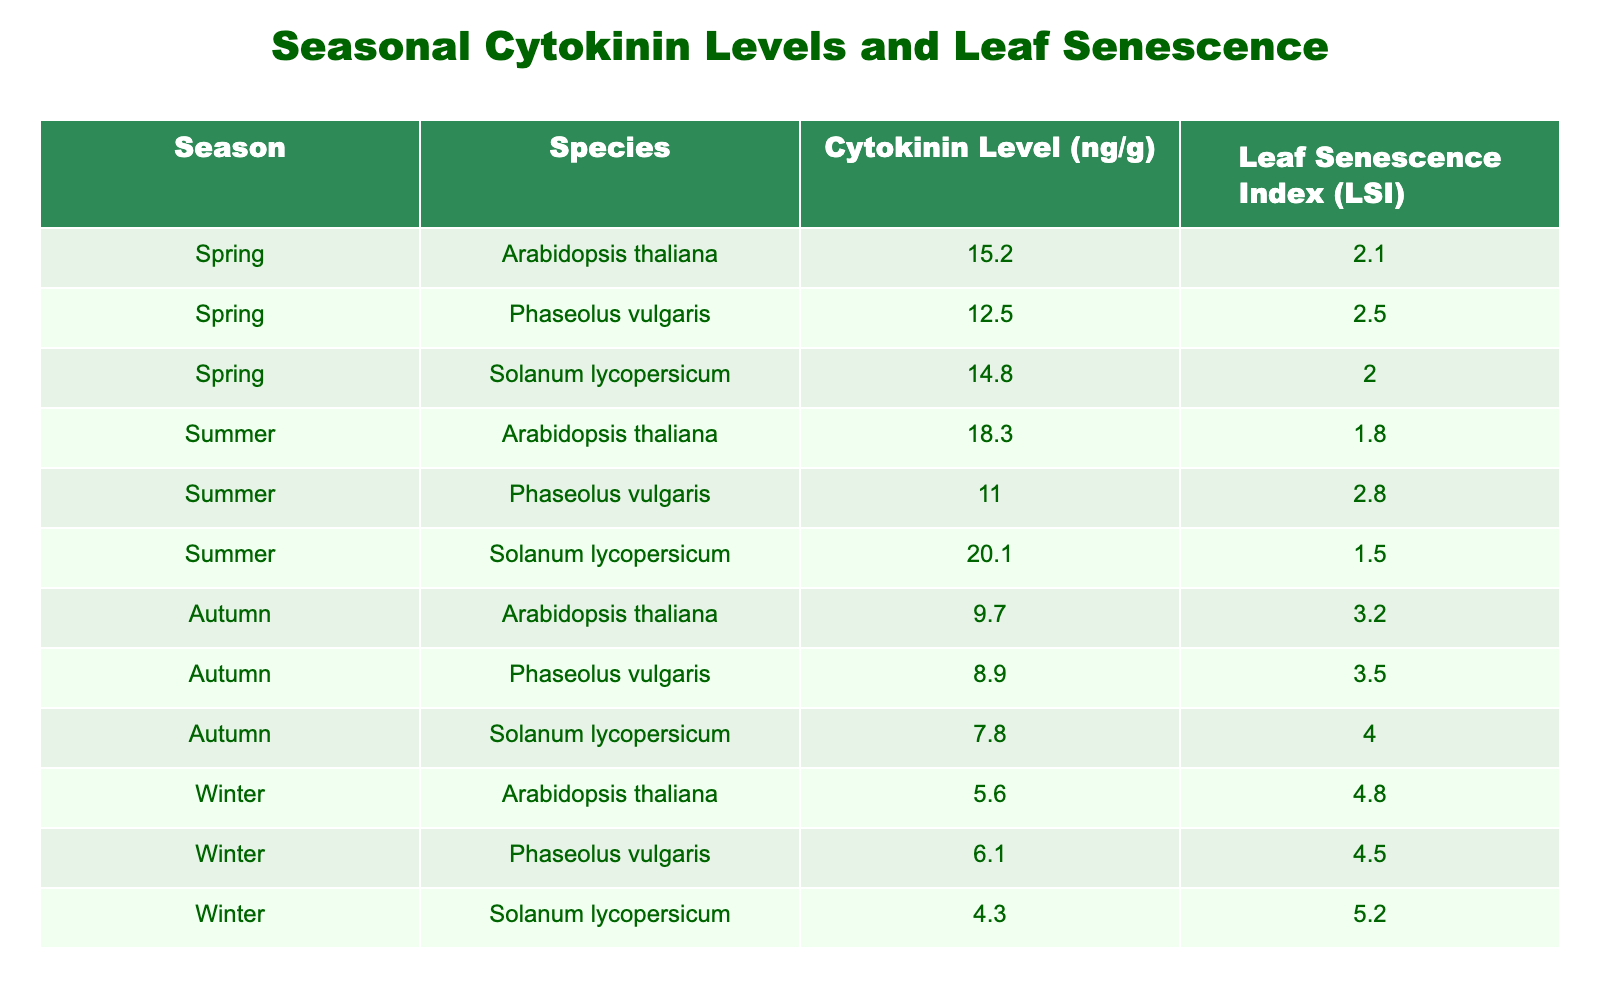What is the cytokinin level for Arabidopsis thaliana in autumn? In the table, look for the row where the species is Arabidopsis thaliana and the season is autumn. The cytokinin level listed in that row is 9.7 ng/g.
Answer: 9.7 ng/g What is the Leaf Senescence Index for Solanum lycopersicum in summer? The table indicates that for Solanum lycopersicum during the summer season, the Leaf Senescence Index (LSI) is listed as 1.5.
Answer: 1.5 Which species exhibited the highest cytokinin level in spring? To determine this, compare the cytokinin levels of all species listed for the spring season. Arabidopsis thaliana at 15.2 ng/g has the highest value among them.
Answer: Arabidopsis thaliana What is the average cytokinin level across all species in winter? First, we find the cytokinin levels for winter: 5.6, 6.1, and 4.3 ng/g. The sum is (5.6 + 6.1 + 4.3) = 16.0. Since there are 3 data points, the average is 16.0 / 3 ≈ 5.33 ng/g.
Answer: 5.33 ng/g Is it true that Phaseolus vulgaris has a lower Leaf Senescence Index in spring than in autumn? Checking the LSI values: Phaseolus vulgaris has an LSI of 2.5 in spring and 3.5 in autumn. Since 2.5 is lower than 3.5, the statement is true.
Answer: Yes What is the difference in cytokinin levels between the highest and lowest values observed across all seasons for Solanum lycopersicum? The highest cytokinin level for Solanum lycopersicum is in summer at 20.1 ng/g, and the lowest is in autumn at 7.8 ng/g. The difference is 20.1 - 7.8 = 12.3 ng/g.
Answer: 12.3 ng/g Which season had the lowest average Leaf Senescence Index across all species? Calculate the average LSI for each season: Spring: (2.1 + 2.5 + 2.0) / 3 = 2.2, Summer: (1.8 + 2.8 + 1.5) / 3 = 2.03, Autumn: (3.2 + 3.5 + 4.0) / 3 = 3.23, Winter: (4.8 + 4.5 + 5.2) / 3 = 4.5. Summer had the lowest average LSI of 2.03.
Answer: Summer What is the trend of cytokinin levels from spring to winter for Arabidopsis thaliana? Observing the table, the cytokinin levels for Arabidopsis thaliana are 15.2 in spring, 18.3 in summer, 9.7 in autumn, and 5.6 in winter. The trend shows a peak in summer followed by a decline in autumn and winter.
Answer: Declining trend How does the Leaf Senescence Index for Phaseolus vulgaris change from summer to winter? The LSI for Phaseolus vulgaris in summer is 2.8, and in winter, it is 4.5. So, there is an increase in the index going from summer to winter.
Answer: It increases What is the sum of cytokinin levels for all species in autumn? Looking at the values for autumn for each species: Arabidopsis thaliana 9.7, Phaseolus vulgaris 8.9, and Solanum lycopersicum 7.8. The total sum is (9.7 + 8.9 + 7.8) = 26.4 ng/g.
Answer: 26.4 ng/g 